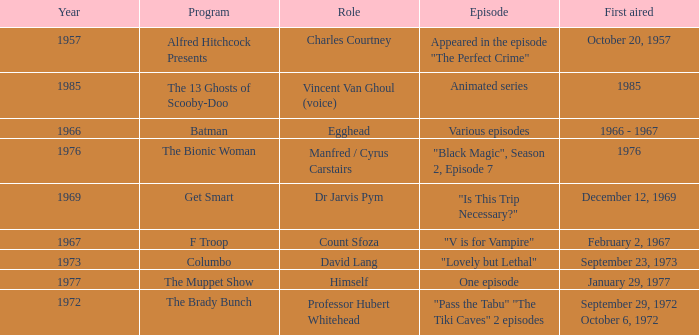What's the roles of the Bionic Woman? Manfred / Cyrus Carstairs. 